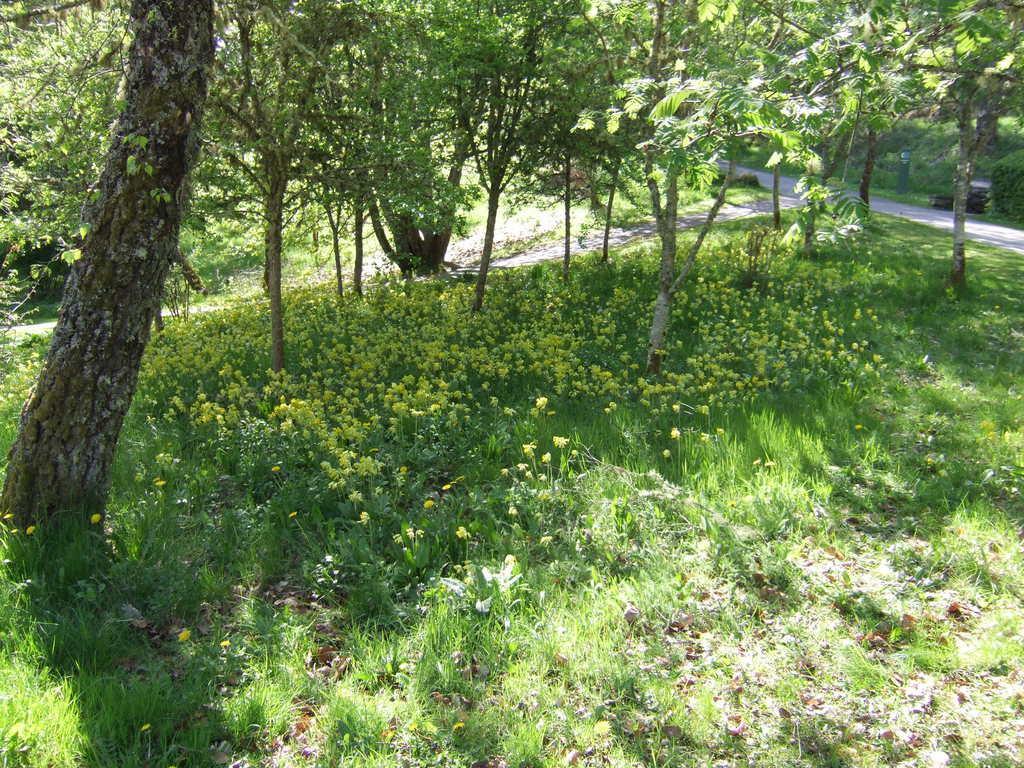In one or two sentences, can you explain what this image depicts? This picture might be taken from outside of the city. In this image, in the background, we can see some trees. On the left side, we can see a wooden trunk. At the bottom, we can see some plants with flowers and a road. 